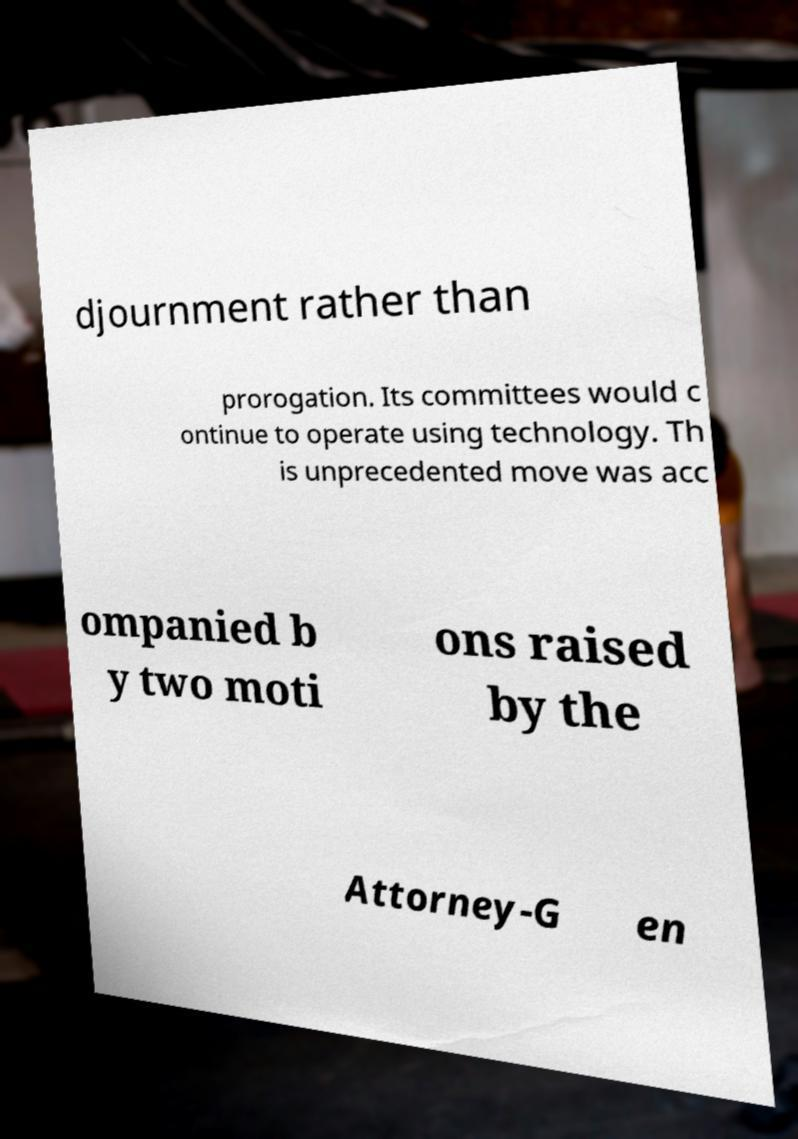Please identify and transcribe the text found in this image. djournment rather than prorogation. Its committees would c ontinue to operate using technology. Th is unprecedented move was acc ompanied b y two moti ons raised by the Attorney-G en 